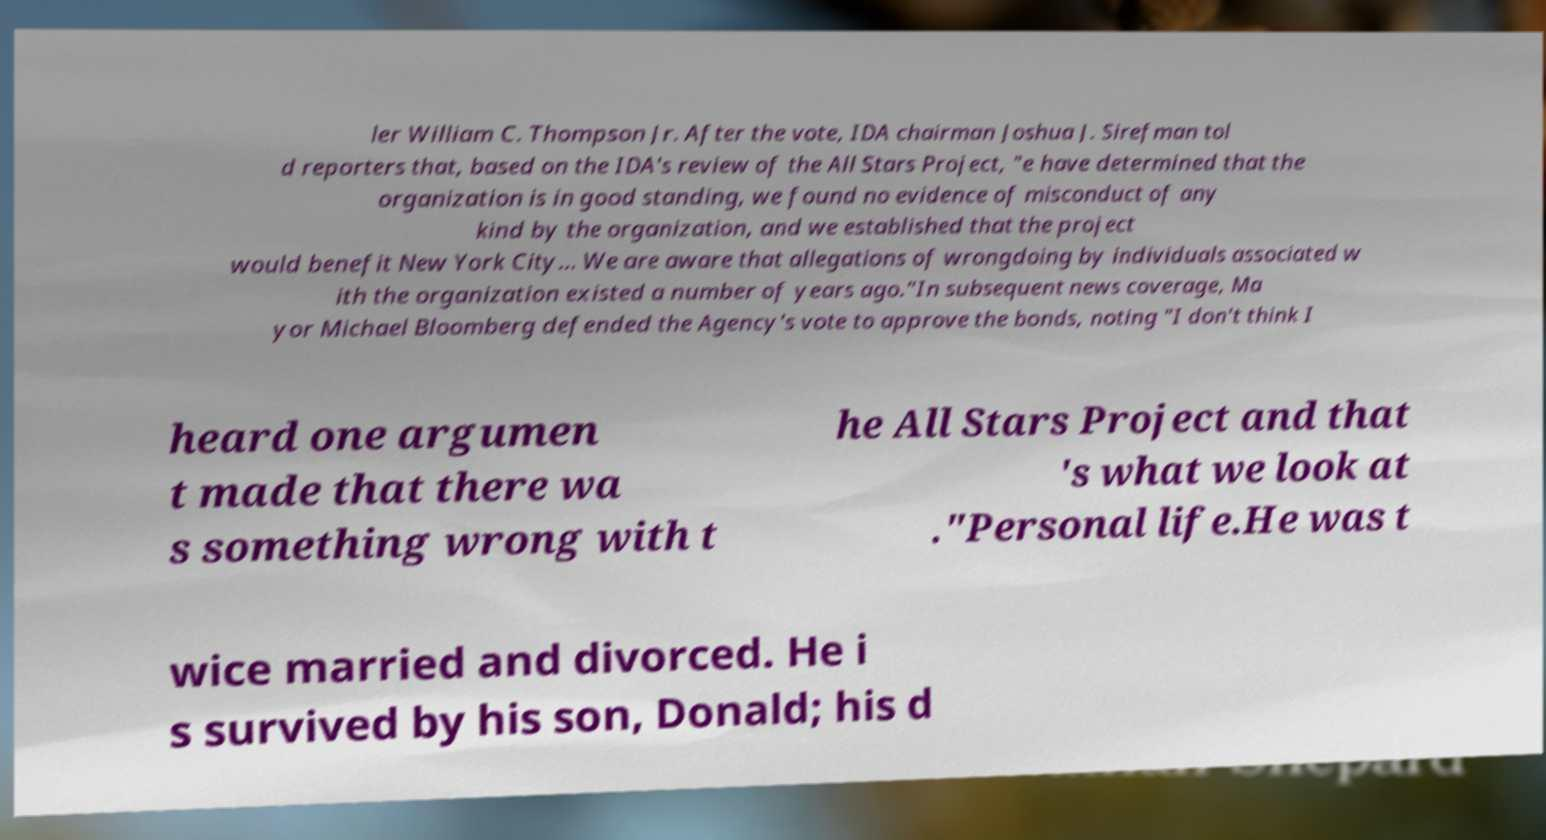Could you extract and type out the text from this image? ler William C. Thompson Jr. After the vote, IDA chairman Joshua J. Sirefman tol d reporters that, based on the IDA's review of the All Stars Project, "e have determined that the organization is in good standing, we found no evidence of misconduct of any kind by the organization, and we established that the project would benefit New York City... We are aware that allegations of wrongdoing by individuals associated w ith the organization existed a number of years ago."In subsequent news coverage, Ma yor Michael Bloomberg defended the Agency's vote to approve the bonds, noting "I don't think I heard one argumen t made that there wa s something wrong with t he All Stars Project and that 's what we look at ."Personal life.He was t wice married and divorced. He i s survived by his son, Donald; his d 